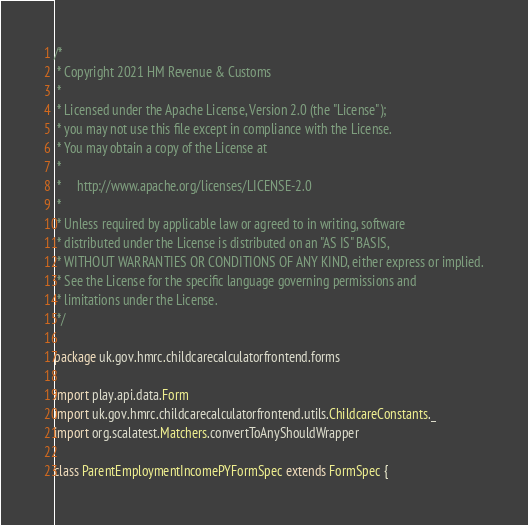<code> <loc_0><loc_0><loc_500><loc_500><_Scala_>/*
 * Copyright 2021 HM Revenue & Customs
 *
 * Licensed under the Apache License, Version 2.0 (the "License");
 * you may not use this file except in compliance with the License.
 * You may obtain a copy of the License at
 *
 *     http://www.apache.org/licenses/LICENSE-2.0
 *
 * Unless required by applicable law or agreed to in writing, software
 * distributed under the License is distributed on an "AS IS" BASIS,
 * WITHOUT WARRANTIES OR CONDITIONS OF ANY KIND, either express or implied.
 * See the License for the specific language governing permissions and
 * limitations under the License.
 */

package uk.gov.hmrc.childcarecalculatorfrontend.forms

import play.api.data.Form
import uk.gov.hmrc.childcarecalculatorfrontend.utils.ChildcareConstants._
import org.scalatest.Matchers.convertToAnyShouldWrapper

class ParentEmploymentIncomePYFormSpec extends FormSpec {

</code> 